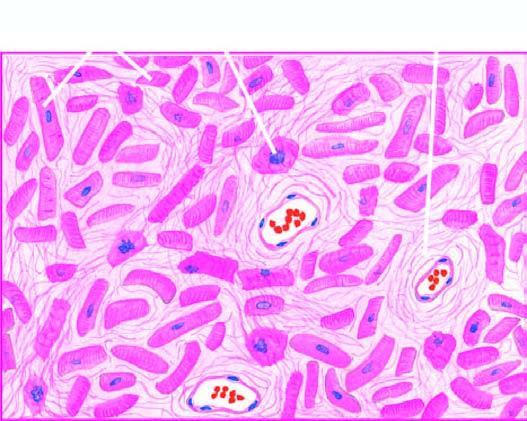s there patchy myocardial fibrosis, especially around small blood vessels in the interstitium?
Answer the question using a single word or phrase. Yes 